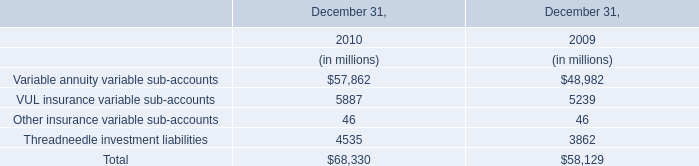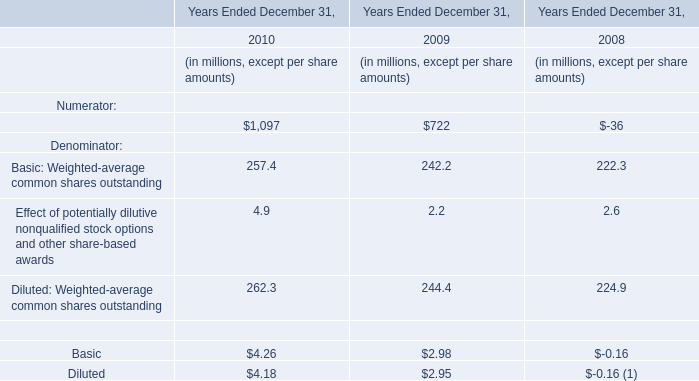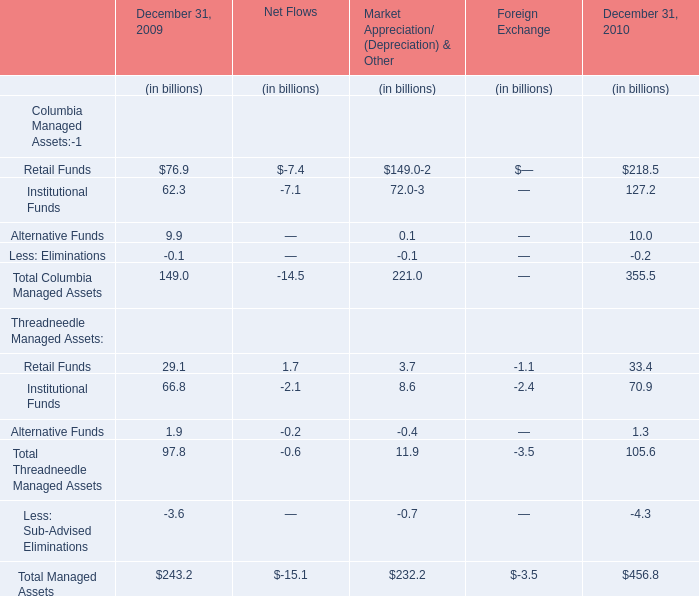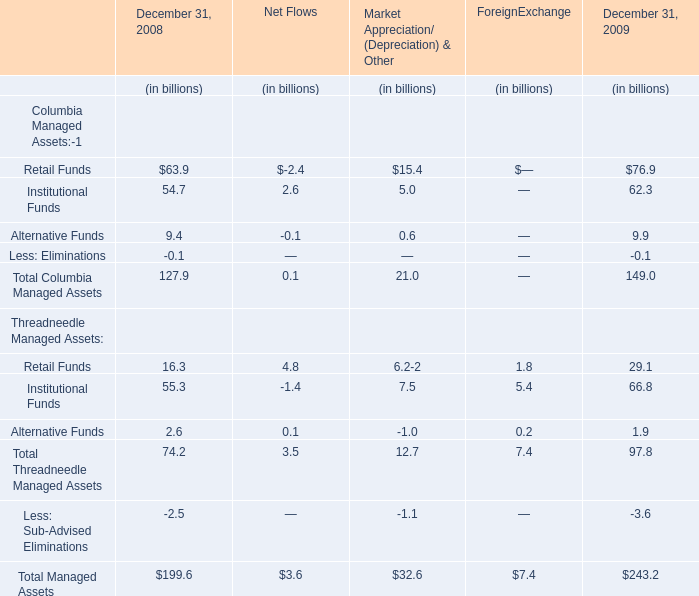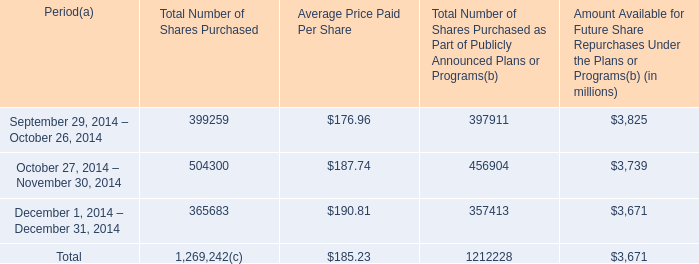What's the current growth rate of Total Managed Assets as ended on December 31? 
Computations: ((243.2 - 199.6) / 199.6)
Answer: 0.21844. 